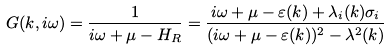Convert formula to latex. <formula><loc_0><loc_0><loc_500><loc_500>G ( k , i \omega ) = \frac { 1 } { i \omega + \mu - H _ { R } } = \frac { i \omega + \mu - \varepsilon ( k ) + \lambda _ { i } ( k ) \sigma _ { i } } { ( i \omega + \mu - \varepsilon ( k ) ) ^ { 2 } - \lambda ^ { 2 } ( k ) }</formula> 